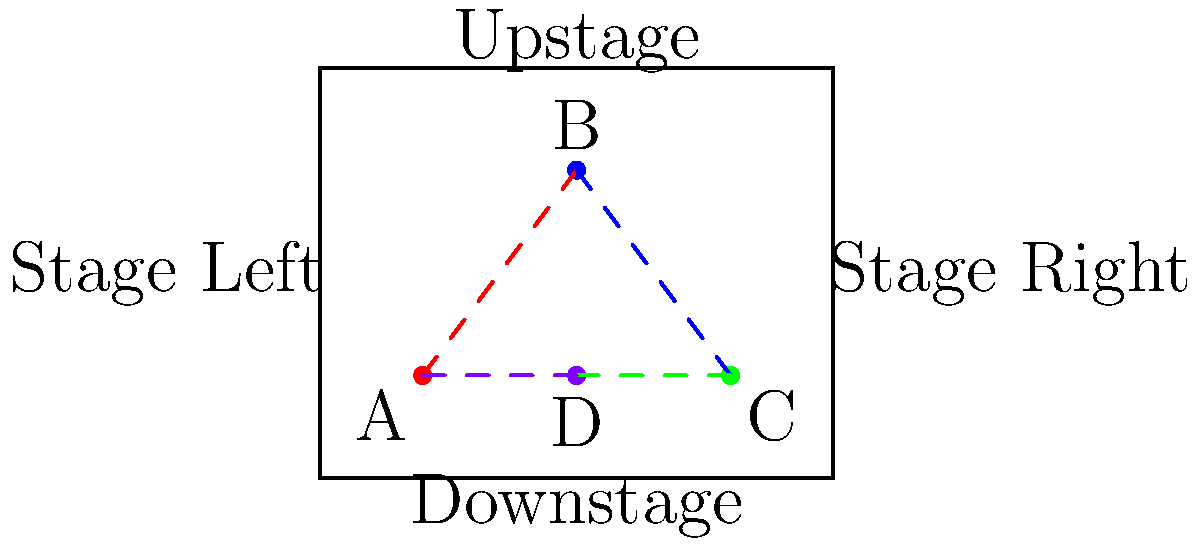In the stage blocking diagram above, actors move in a specific pattern. If the scene starts with Actor A at position A, what is the correct order of movement for all actors to complete one full rotation? To solve this question, we need to analyze the stage blocking pattern shown in the diagram:

1. The stage is represented by a rectangular box, with four actor positions marked A, B, C, and D.
2. The dashed lines indicate the movement paths between these positions.
3. To complete one full rotation, each actor must move through all four positions and return to their starting point.
4. Observing the movement paths, we can see that:
   - Actor A starts at position A
   - The path from A leads to position B
   - From B, the path leads to position C
   - From C, the path leads to position D
   - Finally, from D, the path returns to position A

5. Therefore, the correct order of movement for all actors to complete one full rotation is:
   A → B → C → D → A

This pattern ensures that each actor moves through all positions and returns to their starting point, completing the rotation in a clockwise manner on the stage.
Answer: A → B → C → D → A 